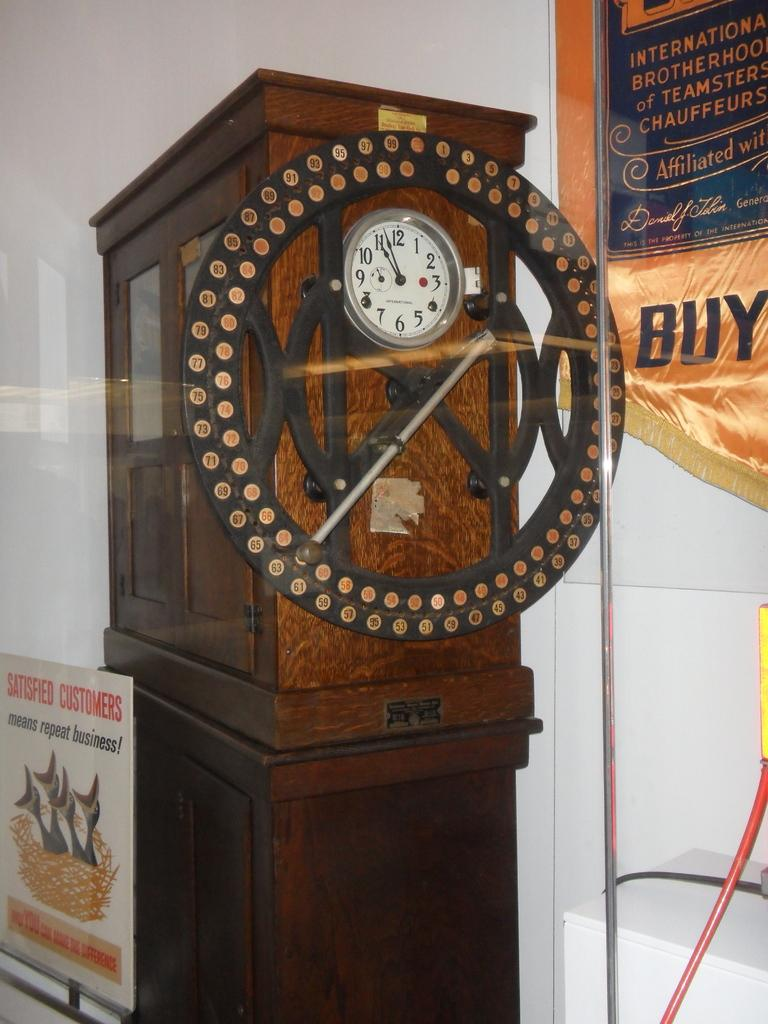<image>
Relay a brief, clear account of the picture shown. A sign states that satisfied customers mean repeat business. 